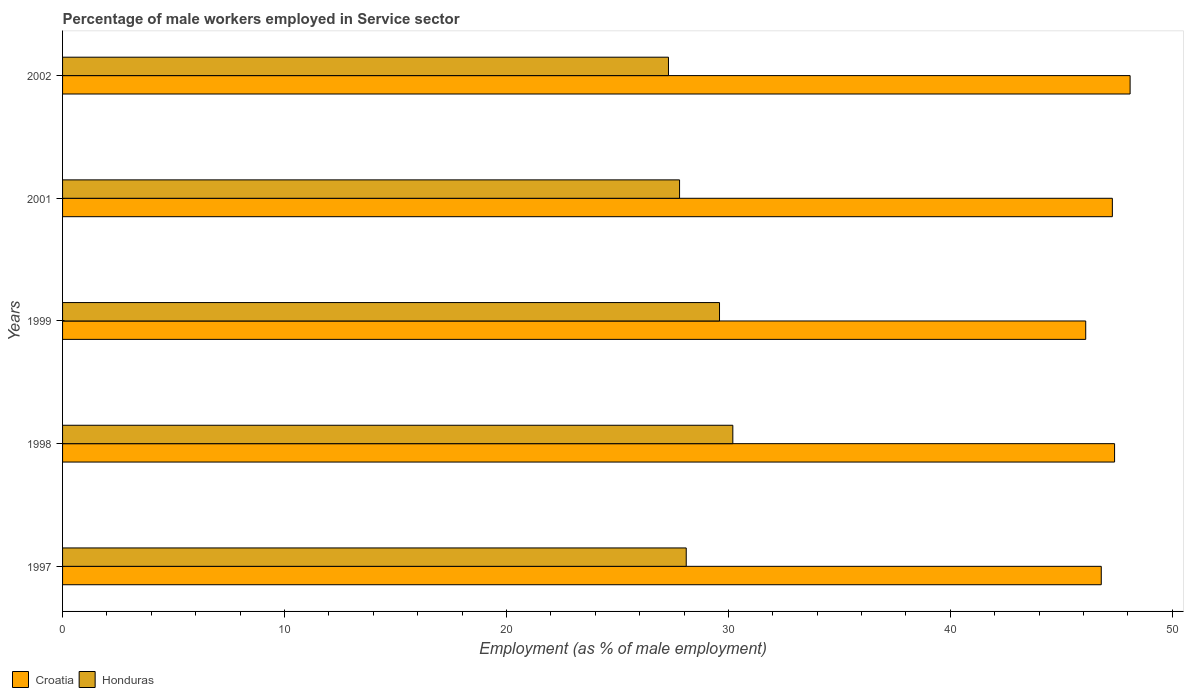How many different coloured bars are there?
Give a very brief answer. 2. How many groups of bars are there?
Your answer should be compact. 5. Are the number of bars on each tick of the Y-axis equal?
Offer a terse response. Yes. How many bars are there on the 2nd tick from the top?
Ensure brevity in your answer.  2. How many bars are there on the 2nd tick from the bottom?
Offer a very short reply. 2. What is the label of the 3rd group of bars from the top?
Provide a short and direct response. 1999. What is the percentage of male workers employed in Service sector in Honduras in 2001?
Provide a short and direct response. 27.8. Across all years, what is the maximum percentage of male workers employed in Service sector in Croatia?
Offer a very short reply. 48.1. Across all years, what is the minimum percentage of male workers employed in Service sector in Croatia?
Keep it short and to the point. 46.1. In which year was the percentage of male workers employed in Service sector in Honduras minimum?
Make the answer very short. 2002. What is the total percentage of male workers employed in Service sector in Honduras in the graph?
Offer a very short reply. 143. What is the difference between the percentage of male workers employed in Service sector in Croatia in 2001 and the percentage of male workers employed in Service sector in Honduras in 2002?
Give a very brief answer. 20. What is the average percentage of male workers employed in Service sector in Honduras per year?
Keep it short and to the point. 28.6. In the year 1999, what is the difference between the percentage of male workers employed in Service sector in Honduras and percentage of male workers employed in Service sector in Croatia?
Keep it short and to the point. -16.5. What is the ratio of the percentage of male workers employed in Service sector in Honduras in 1997 to that in 1999?
Your answer should be compact. 0.95. Is the percentage of male workers employed in Service sector in Honduras in 1999 less than that in 2001?
Your answer should be compact. No. What is the difference between the highest and the second highest percentage of male workers employed in Service sector in Croatia?
Keep it short and to the point. 0.7. What is the difference between the highest and the lowest percentage of male workers employed in Service sector in Honduras?
Provide a succinct answer. 2.9. What does the 1st bar from the top in 2002 represents?
Your response must be concise. Honduras. What does the 1st bar from the bottom in 1997 represents?
Your response must be concise. Croatia. How many bars are there?
Ensure brevity in your answer.  10. How many years are there in the graph?
Your answer should be very brief. 5. Does the graph contain any zero values?
Offer a very short reply. No. Does the graph contain grids?
Provide a short and direct response. No. Where does the legend appear in the graph?
Offer a terse response. Bottom left. How many legend labels are there?
Provide a short and direct response. 2. What is the title of the graph?
Ensure brevity in your answer.  Percentage of male workers employed in Service sector. Does "Micronesia" appear as one of the legend labels in the graph?
Give a very brief answer. No. What is the label or title of the X-axis?
Provide a succinct answer. Employment (as % of male employment). What is the label or title of the Y-axis?
Your response must be concise. Years. What is the Employment (as % of male employment) in Croatia in 1997?
Provide a succinct answer. 46.8. What is the Employment (as % of male employment) in Honduras in 1997?
Your answer should be compact. 28.1. What is the Employment (as % of male employment) in Croatia in 1998?
Give a very brief answer. 47.4. What is the Employment (as % of male employment) of Honduras in 1998?
Offer a very short reply. 30.2. What is the Employment (as % of male employment) in Croatia in 1999?
Ensure brevity in your answer.  46.1. What is the Employment (as % of male employment) in Honduras in 1999?
Your answer should be compact. 29.6. What is the Employment (as % of male employment) in Croatia in 2001?
Make the answer very short. 47.3. What is the Employment (as % of male employment) in Honduras in 2001?
Make the answer very short. 27.8. What is the Employment (as % of male employment) of Croatia in 2002?
Give a very brief answer. 48.1. What is the Employment (as % of male employment) of Honduras in 2002?
Your answer should be very brief. 27.3. Across all years, what is the maximum Employment (as % of male employment) in Croatia?
Offer a terse response. 48.1. Across all years, what is the maximum Employment (as % of male employment) of Honduras?
Make the answer very short. 30.2. Across all years, what is the minimum Employment (as % of male employment) of Croatia?
Your answer should be compact. 46.1. Across all years, what is the minimum Employment (as % of male employment) in Honduras?
Offer a very short reply. 27.3. What is the total Employment (as % of male employment) of Croatia in the graph?
Give a very brief answer. 235.7. What is the total Employment (as % of male employment) of Honduras in the graph?
Offer a very short reply. 143. What is the difference between the Employment (as % of male employment) in Croatia in 1997 and that in 1999?
Make the answer very short. 0.7. What is the difference between the Employment (as % of male employment) of Honduras in 1997 and that in 1999?
Provide a succinct answer. -1.5. What is the difference between the Employment (as % of male employment) in Honduras in 1997 and that in 2002?
Offer a very short reply. 0.8. What is the difference between the Employment (as % of male employment) in Honduras in 1998 and that in 1999?
Your answer should be very brief. 0.6. What is the difference between the Employment (as % of male employment) of Croatia in 1998 and that in 2002?
Give a very brief answer. -0.7. What is the difference between the Employment (as % of male employment) of Croatia in 1999 and that in 2002?
Ensure brevity in your answer.  -2. What is the difference between the Employment (as % of male employment) in Honduras in 1999 and that in 2002?
Keep it short and to the point. 2.3. What is the difference between the Employment (as % of male employment) of Croatia in 2001 and that in 2002?
Make the answer very short. -0.8. What is the difference between the Employment (as % of male employment) in Honduras in 2001 and that in 2002?
Make the answer very short. 0.5. What is the difference between the Employment (as % of male employment) of Croatia in 1997 and the Employment (as % of male employment) of Honduras in 1998?
Make the answer very short. 16.6. What is the difference between the Employment (as % of male employment) in Croatia in 1997 and the Employment (as % of male employment) in Honduras in 2001?
Your answer should be very brief. 19. What is the difference between the Employment (as % of male employment) of Croatia in 1998 and the Employment (as % of male employment) of Honduras in 1999?
Provide a succinct answer. 17.8. What is the difference between the Employment (as % of male employment) in Croatia in 1998 and the Employment (as % of male employment) in Honduras in 2001?
Make the answer very short. 19.6. What is the difference between the Employment (as % of male employment) of Croatia in 1998 and the Employment (as % of male employment) of Honduras in 2002?
Ensure brevity in your answer.  20.1. What is the difference between the Employment (as % of male employment) in Croatia in 1999 and the Employment (as % of male employment) in Honduras in 2001?
Provide a succinct answer. 18.3. What is the difference between the Employment (as % of male employment) in Croatia in 1999 and the Employment (as % of male employment) in Honduras in 2002?
Keep it short and to the point. 18.8. What is the average Employment (as % of male employment) in Croatia per year?
Provide a short and direct response. 47.14. What is the average Employment (as % of male employment) in Honduras per year?
Give a very brief answer. 28.6. In the year 2001, what is the difference between the Employment (as % of male employment) of Croatia and Employment (as % of male employment) of Honduras?
Make the answer very short. 19.5. In the year 2002, what is the difference between the Employment (as % of male employment) in Croatia and Employment (as % of male employment) in Honduras?
Give a very brief answer. 20.8. What is the ratio of the Employment (as % of male employment) of Croatia in 1997 to that in 1998?
Ensure brevity in your answer.  0.99. What is the ratio of the Employment (as % of male employment) of Honduras in 1997 to that in 1998?
Ensure brevity in your answer.  0.93. What is the ratio of the Employment (as % of male employment) in Croatia in 1997 to that in 1999?
Offer a terse response. 1.02. What is the ratio of the Employment (as % of male employment) in Honduras in 1997 to that in 1999?
Ensure brevity in your answer.  0.95. What is the ratio of the Employment (as % of male employment) of Croatia in 1997 to that in 2001?
Provide a succinct answer. 0.99. What is the ratio of the Employment (as % of male employment) in Honduras in 1997 to that in 2001?
Make the answer very short. 1.01. What is the ratio of the Employment (as % of male employment) in Honduras in 1997 to that in 2002?
Provide a succinct answer. 1.03. What is the ratio of the Employment (as % of male employment) of Croatia in 1998 to that in 1999?
Offer a very short reply. 1.03. What is the ratio of the Employment (as % of male employment) in Honduras in 1998 to that in 1999?
Your response must be concise. 1.02. What is the ratio of the Employment (as % of male employment) in Croatia in 1998 to that in 2001?
Your answer should be compact. 1. What is the ratio of the Employment (as % of male employment) of Honduras in 1998 to that in 2001?
Keep it short and to the point. 1.09. What is the ratio of the Employment (as % of male employment) in Croatia in 1998 to that in 2002?
Your answer should be very brief. 0.99. What is the ratio of the Employment (as % of male employment) of Honduras in 1998 to that in 2002?
Offer a very short reply. 1.11. What is the ratio of the Employment (as % of male employment) in Croatia in 1999 to that in 2001?
Offer a terse response. 0.97. What is the ratio of the Employment (as % of male employment) in Honduras in 1999 to that in 2001?
Your answer should be very brief. 1.06. What is the ratio of the Employment (as % of male employment) in Croatia in 1999 to that in 2002?
Your answer should be compact. 0.96. What is the ratio of the Employment (as % of male employment) in Honduras in 1999 to that in 2002?
Your response must be concise. 1.08. What is the ratio of the Employment (as % of male employment) in Croatia in 2001 to that in 2002?
Your answer should be compact. 0.98. What is the ratio of the Employment (as % of male employment) of Honduras in 2001 to that in 2002?
Your answer should be compact. 1.02. What is the difference between the highest and the second highest Employment (as % of male employment) in Croatia?
Keep it short and to the point. 0.7. What is the difference between the highest and the lowest Employment (as % of male employment) of Croatia?
Offer a very short reply. 2. 